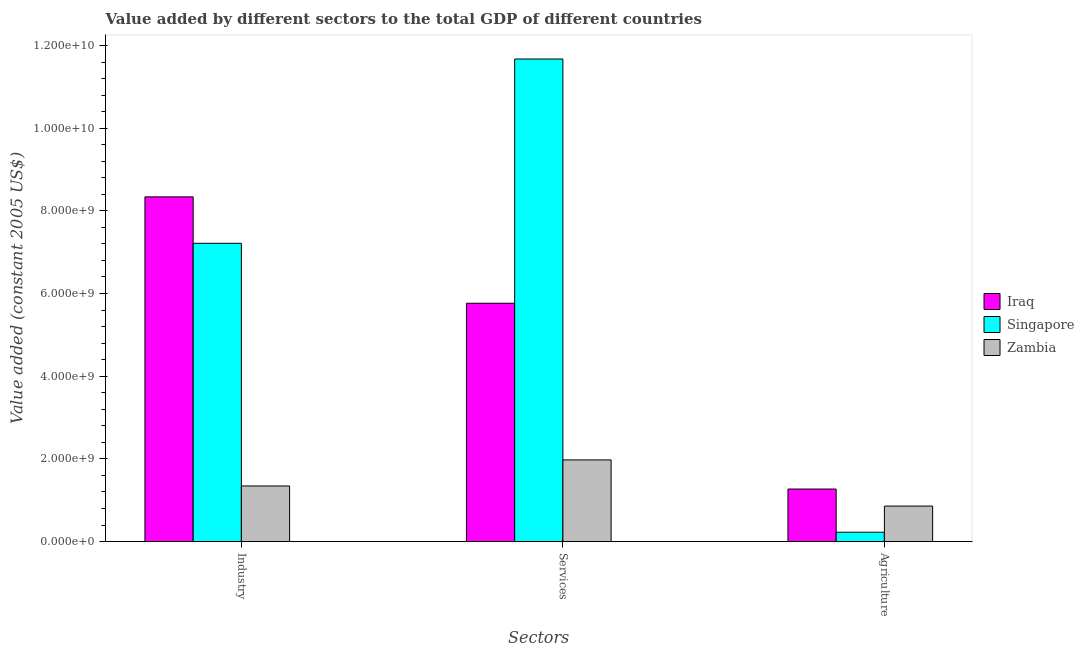How many different coloured bars are there?
Provide a short and direct response. 3. Are the number of bars per tick equal to the number of legend labels?
Provide a short and direct response. Yes. Are the number of bars on each tick of the X-axis equal?
Offer a terse response. Yes. What is the label of the 3rd group of bars from the left?
Your answer should be very brief. Agriculture. What is the value added by services in Singapore?
Your answer should be very brief. 1.17e+1. Across all countries, what is the maximum value added by industrial sector?
Your response must be concise. 8.34e+09. Across all countries, what is the minimum value added by services?
Offer a terse response. 1.97e+09. In which country was the value added by services maximum?
Offer a terse response. Singapore. In which country was the value added by services minimum?
Provide a succinct answer. Zambia. What is the total value added by services in the graph?
Your response must be concise. 1.94e+1. What is the difference between the value added by agricultural sector in Singapore and that in Zambia?
Make the answer very short. -6.32e+08. What is the difference between the value added by services in Zambia and the value added by agricultural sector in Singapore?
Ensure brevity in your answer.  1.75e+09. What is the average value added by industrial sector per country?
Provide a succinct answer. 5.63e+09. What is the difference between the value added by agricultural sector and value added by services in Zambia?
Offer a very short reply. -1.12e+09. What is the ratio of the value added by agricultural sector in Iraq to that in Singapore?
Provide a succinct answer. 5.62. Is the value added by services in Iraq less than that in Zambia?
Provide a short and direct response. No. Is the difference between the value added by industrial sector in Singapore and Zambia greater than the difference between the value added by agricultural sector in Singapore and Zambia?
Make the answer very short. Yes. What is the difference between the highest and the second highest value added by agricultural sector?
Your answer should be very brief. 4.12e+08. What is the difference between the highest and the lowest value added by industrial sector?
Your answer should be very brief. 6.99e+09. In how many countries, is the value added by agricultural sector greater than the average value added by agricultural sector taken over all countries?
Provide a succinct answer. 2. Is the sum of the value added by agricultural sector in Iraq and Zambia greater than the maximum value added by services across all countries?
Give a very brief answer. No. What does the 2nd bar from the left in Industry represents?
Your answer should be compact. Singapore. What does the 1st bar from the right in Industry represents?
Your answer should be compact. Zambia. Is it the case that in every country, the sum of the value added by industrial sector and value added by services is greater than the value added by agricultural sector?
Keep it short and to the point. Yes. What is the difference between two consecutive major ticks on the Y-axis?
Your response must be concise. 2.00e+09. Are the values on the major ticks of Y-axis written in scientific E-notation?
Your response must be concise. Yes. Does the graph contain grids?
Make the answer very short. No. Where does the legend appear in the graph?
Ensure brevity in your answer.  Center right. How many legend labels are there?
Keep it short and to the point. 3. How are the legend labels stacked?
Give a very brief answer. Vertical. What is the title of the graph?
Your response must be concise. Value added by different sectors to the total GDP of different countries. What is the label or title of the X-axis?
Give a very brief answer. Sectors. What is the label or title of the Y-axis?
Offer a very short reply. Value added (constant 2005 US$). What is the Value added (constant 2005 US$) in Iraq in Industry?
Your response must be concise. 8.34e+09. What is the Value added (constant 2005 US$) in Singapore in Industry?
Your response must be concise. 7.21e+09. What is the Value added (constant 2005 US$) in Zambia in Industry?
Offer a terse response. 1.34e+09. What is the Value added (constant 2005 US$) in Iraq in Services?
Keep it short and to the point. 5.76e+09. What is the Value added (constant 2005 US$) in Singapore in Services?
Your answer should be very brief. 1.17e+1. What is the Value added (constant 2005 US$) in Zambia in Services?
Ensure brevity in your answer.  1.97e+09. What is the Value added (constant 2005 US$) in Iraq in Agriculture?
Provide a short and direct response. 1.27e+09. What is the Value added (constant 2005 US$) of Singapore in Agriculture?
Provide a short and direct response. 2.26e+08. What is the Value added (constant 2005 US$) of Zambia in Agriculture?
Offer a very short reply. 8.58e+08. Across all Sectors, what is the maximum Value added (constant 2005 US$) in Iraq?
Your answer should be very brief. 8.34e+09. Across all Sectors, what is the maximum Value added (constant 2005 US$) in Singapore?
Give a very brief answer. 1.17e+1. Across all Sectors, what is the maximum Value added (constant 2005 US$) in Zambia?
Ensure brevity in your answer.  1.97e+09. Across all Sectors, what is the minimum Value added (constant 2005 US$) in Iraq?
Give a very brief answer. 1.27e+09. Across all Sectors, what is the minimum Value added (constant 2005 US$) of Singapore?
Make the answer very short. 2.26e+08. Across all Sectors, what is the minimum Value added (constant 2005 US$) of Zambia?
Your response must be concise. 8.58e+08. What is the total Value added (constant 2005 US$) of Iraq in the graph?
Keep it short and to the point. 1.54e+1. What is the total Value added (constant 2005 US$) in Singapore in the graph?
Give a very brief answer. 1.91e+1. What is the total Value added (constant 2005 US$) of Zambia in the graph?
Give a very brief answer. 4.18e+09. What is the difference between the Value added (constant 2005 US$) in Iraq in Industry and that in Services?
Provide a succinct answer. 2.57e+09. What is the difference between the Value added (constant 2005 US$) of Singapore in Industry and that in Services?
Keep it short and to the point. -4.46e+09. What is the difference between the Value added (constant 2005 US$) in Zambia in Industry and that in Services?
Your answer should be very brief. -6.30e+08. What is the difference between the Value added (constant 2005 US$) of Iraq in Industry and that in Agriculture?
Ensure brevity in your answer.  7.07e+09. What is the difference between the Value added (constant 2005 US$) of Singapore in Industry and that in Agriculture?
Offer a terse response. 6.99e+09. What is the difference between the Value added (constant 2005 US$) in Zambia in Industry and that in Agriculture?
Your answer should be very brief. 4.86e+08. What is the difference between the Value added (constant 2005 US$) of Iraq in Services and that in Agriculture?
Keep it short and to the point. 4.49e+09. What is the difference between the Value added (constant 2005 US$) of Singapore in Services and that in Agriculture?
Ensure brevity in your answer.  1.14e+1. What is the difference between the Value added (constant 2005 US$) of Zambia in Services and that in Agriculture?
Your answer should be compact. 1.12e+09. What is the difference between the Value added (constant 2005 US$) of Iraq in Industry and the Value added (constant 2005 US$) of Singapore in Services?
Your answer should be very brief. -3.34e+09. What is the difference between the Value added (constant 2005 US$) in Iraq in Industry and the Value added (constant 2005 US$) in Zambia in Services?
Make the answer very short. 6.36e+09. What is the difference between the Value added (constant 2005 US$) of Singapore in Industry and the Value added (constant 2005 US$) of Zambia in Services?
Offer a very short reply. 5.24e+09. What is the difference between the Value added (constant 2005 US$) in Iraq in Industry and the Value added (constant 2005 US$) in Singapore in Agriculture?
Make the answer very short. 8.11e+09. What is the difference between the Value added (constant 2005 US$) in Iraq in Industry and the Value added (constant 2005 US$) in Zambia in Agriculture?
Ensure brevity in your answer.  7.48e+09. What is the difference between the Value added (constant 2005 US$) in Singapore in Industry and the Value added (constant 2005 US$) in Zambia in Agriculture?
Give a very brief answer. 6.36e+09. What is the difference between the Value added (constant 2005 US$) of Iraq in Services and the Value added (constant 2005 US$) of Singapore in Agriculture?
Provide a short and direct response. 5.54e+09. What is the difference between the Value added (constant 2005 US$) of Iraq in Services and the Value added (constant 2005 US$) of Zambia in Agriculture?
Your answer should be very brief. 4.91e+09. What is the difference between the Value added (constant 2005 US$) of Singapore in Services and the Value added (constant 2005 US$) of Zambia in Agriculture?
Your response must be concise. 1.08e+1. What is the average Value added (constant 2005 US$) of Iraq per Sectors?
Your answer should be compact. 5.12e+09. What is the average Value added (constant 2005 US$) of Singapore per Sectors?
Your response must be concise. 6.37e+09. What is the average Value added (constant 2005 US$) of Zambia per Sectors?
Offer a terse response. 1.39e+09. What is the difference between the Value added (constant 2005 US$) in Iraq and Value added (constant 2005 US$) in Singapore in Industry?
Provide a short and direct response. 1.12e+09. What is the difference between the Value added (constant 2005 US$) in Iraq and Value added (constant 2005 US$) in Zambia in Industry?
Make the answer very short. 6.99e+09. What is the difference between the Value added (constant 2005 US$) in Singapore and Value added (constant 2005 US$) in Zambia in Industry?
Offer a very short reply. 5.87e+09. What is the difference between the Value added (constant 2005 US$) in Iraq and Value added (constant 2005 US$) in Singapore in Services?
Ensure brevity in your answer.  -5.91e+09. What is the difference between the Value added (constant 2005 US$) in Iraq and Value added (constant 2005 US$) in Zambia in Services?
Provide a succinct answer. 3.79e+09. What is the difference between the Value added (constant 2005 US$) of Singapore and Value added (constant 2005 US$) of Zambia in Services?
Make the answer very short. 9.70e+09. What is the difference between the Value added (constant 2005 US$) of Iraq and Value added (constant 2005 US$) of Singapore in Agriculture?
Provide a succinct answer. 1.04e+09. What is the difference between the Value added (constant 2005 US$) in Iraq and Value added (constant 2005 US$) in Zambia in Agriculture?
Offer a very short reply. 4.12e+08. What is the difference between the Value added (constant 2005 US$) of Singapore and Value added (constant 2005 US$) of Zambia in Agriculture?
Offer a terse response. -6.32e+08. What is the ratio of the Value added (constant 2005 US$) of Iraq in Industry to that in Services?
Keep it short and to the point. 1.45. What is the ratio of the Value added (constant 2005 US$) of Singapore in Industry to that in Services?
Ensure brevity in your answer.  0.62. What is the ratio of the Value added (constant 2005 US$) in Zambia in Industry to that in Services?
Your response must be concise. 0.68. What is the ratio of the Value added (constant 2005 US$) in Iraq in Industry to that in Agriculture?
Provide a succinct answer. 6.56. What is the ratio of the Value added (constant 2005 US$) in Singapore in Industry to that in Agriculture?
Provide a succinct answer. 31.92. What is the ratio of the Value added (constant 2005 US$) of Zambia in Industry to that in Agriculture?
Your answer should be compact. 1.57. What is the ratio of the Value added (constant 2005 US$) of Iraq in Services to that in Agriculture?
Give a very brief answer. 4.54. What is the ratio of the Value added (constant 2005 US$) of Singapore in Services to that in Agriculture?
Provide a short and direct response. 51.65. What is the ratio of the Value added (constant 2005 US$) in Zambia in Services to that in Agriculture?
Make the answer very short. 2.3. What is the difference between the highest and the second highest Value added (constant 2005 US$) in Iraq?
Your response must be concise. 2.57e+09. What is the difference between the highest and the second highest Value added (constant 2005 US$) in Singapore?
Make the answer very short. 4.46e+09. What is the difference between the highest and the second highest Value added (constant 2005 US$) of Zambia?
Your answer should be very brief. 6.30e+08. What is the difference between the highest and the lowest Value added (constant 2005 US$) of Iraq?
Provide a succinct answer. 7.07e+09. What is the difference between the highest and the lowest Value added (constant 2005 US$) in Singapore?
Your answer should be very brief. 1.14e+1. What is the difference between the highest and the lowest Value added (constant 2005 US$) in Zambia?
Offer a very short reply. 1.12e+09. 